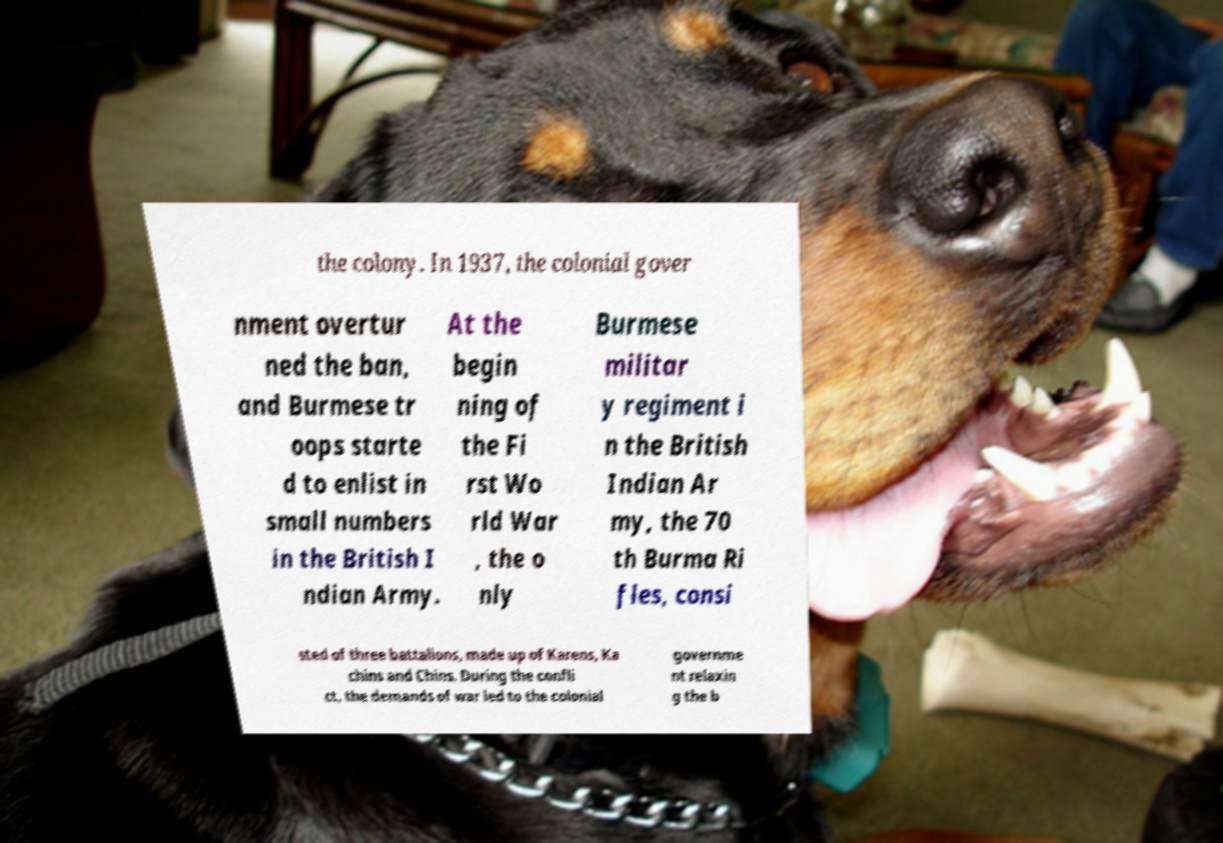Can you accurately transcribe the text from the provided image for me? the colony. In 1937, the colonial gover nment overtur ned the ban, and Burmese tr oops starte d to enlist in small numbers in the British I ndian Army. At the begin ning of the Fi rst Wo rld War , the o nly Burmese militar y regiment i n the British Indian Ar my, the 70 th Burma Ri fles, consi sted of three battalions, made up of Karens, Ka chins and Chins. During the confli ct, the demands of war led to the colonial governme nt relaxin g the b 